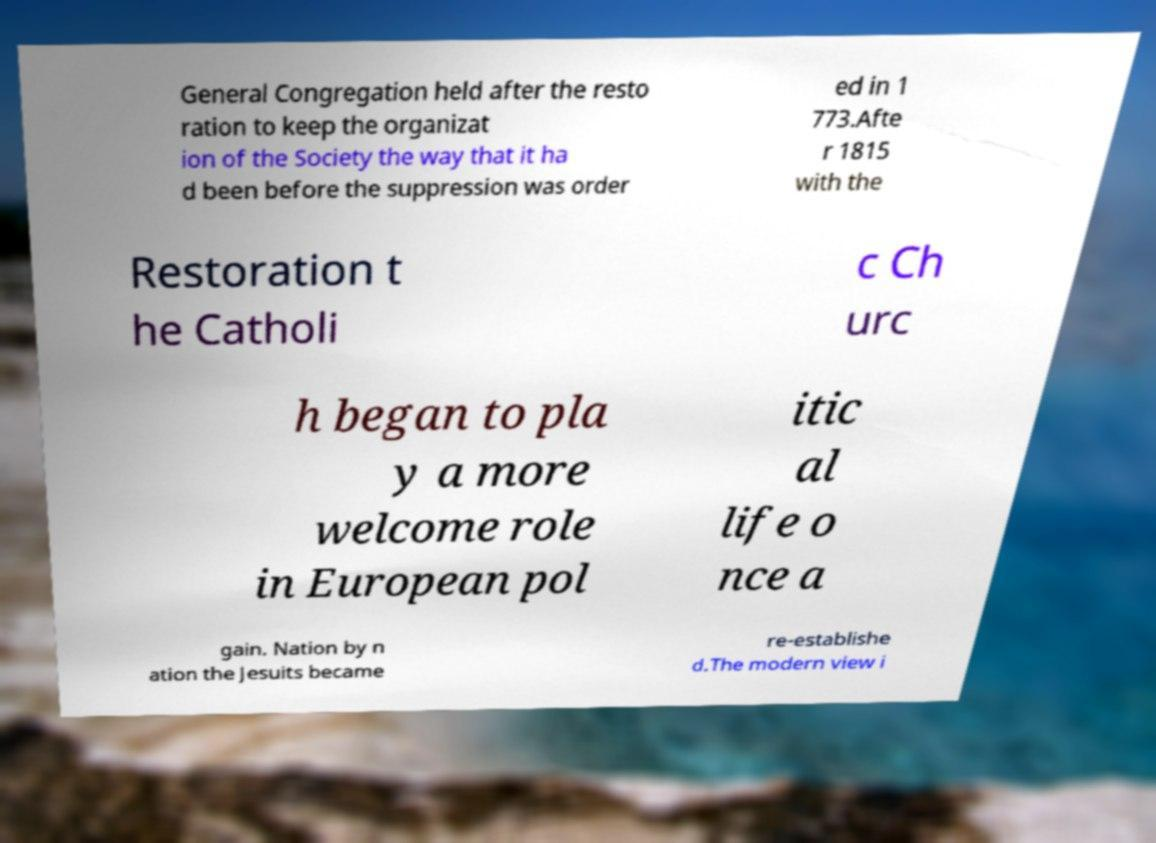Can you read and provide the text displayed in the image?This photo seems to have some interesting text. Can you extract and type it out for me? General Congregation held after the resto ration to keep the organizat ion of the Society the way that it ha d been before the suppression was order ed in 1 773.Afte r 1815 with the Restoration t he Catholi c Ch urc h began to pla y a more welcome role in European pol itic al life o nce a gain. Nation by n ation the Jesuits became re-establishe d.The modern view i 